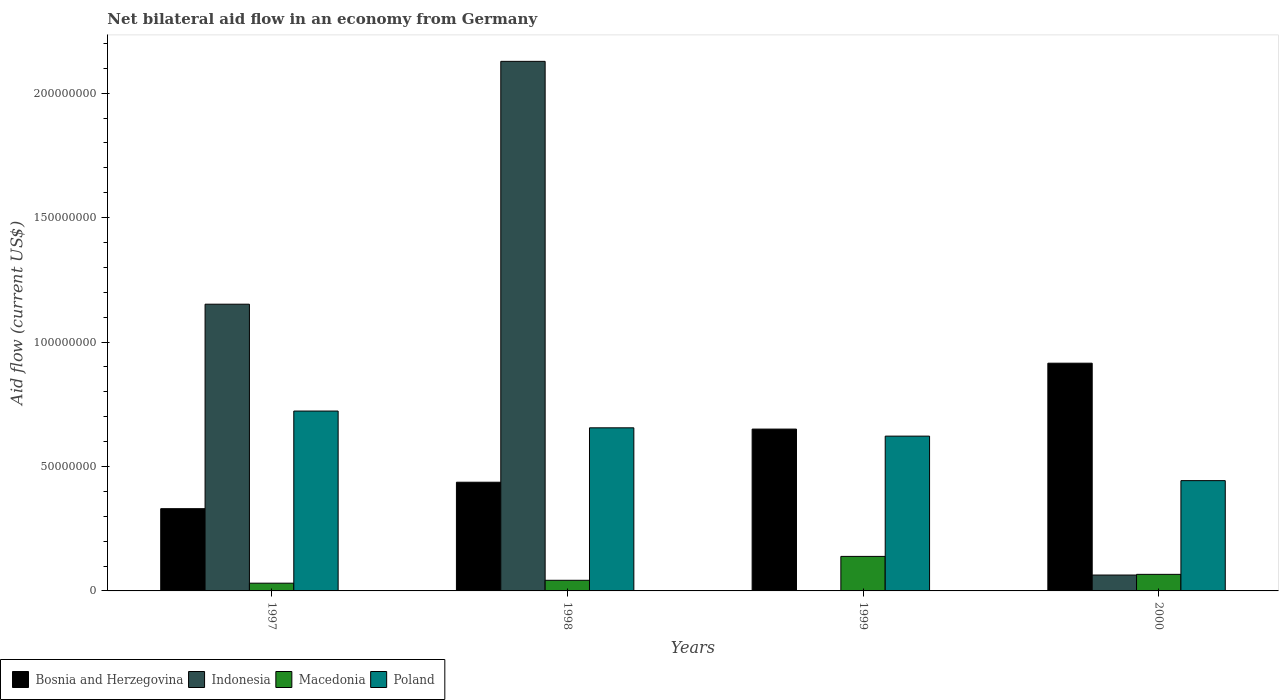How many different coloured bars are there?
Your response must be concise. 4. How many groups of bars are there?
Give a very brief answer. 4. Are the number of bars per tick equal to the number of legend labels?
Provide a succinct answer. No. How many bars are there on the 1st tick from the right?
Ensure brevity in your answer.  4. What is the label of the 4th group of bars from the left?
Offer a terse response. 2000. What is the net bilateral aid flow in Bosnia and Herzegovina in 2000?
Provide a short and direct response. 9.15e+07. Across all years, what is the maximum net bilateral aid flow in Poland?
Your answer should be compact. 7.23e+07. Across all years, what is the minimum net bilateral aid flow in Macedonia?
Make the answer very short. 3.11e+06. In which year was the net bilateral aid flow in Bosnia and Herzegovina maximum?
Ensure brevity in your answer.  2000. What is the total net bilateral aid flow in Macedonia in the graph?
Make the answer very short. 2.79e+07. What is the difference between the net bilateral aid flow in Macedonia in 1998 and that in 1999?
Offer a very short reply. -9.60e+06. What is the difference between the net bilateral aid flow in Indonesia in 2000 and the net bilateral aid flow in Macedonia in 1997?
Give a very brief answer. 3.27e+06. What is the average net bilateral aid flow in Bosnia and Herzegovina per year?
Offer a very short reply. 5.83e+07. In the year 1997, what is the difference between the net bilateral aid flow in Bosnia and Herzegovina and net bilateral aid flow in Poland?
Provide a short and direct response. -3.92e+07. What is the ratio of the net bilateral aid flow in Macedonia in 1997 to that in 1998?
Provide a short and direct response. 0.73. Is the difference between the net bilateral aid flow in Bosnia and Herzegovina in 1997 and 2000 greater than the difference between the net bilateral aid flow in Poland in 1997 and 2000?
Offer a terse response. No. What is the difference between the highest and the second highest net bilateral aid flow in Bosnia and Herzegovina?
Your response must be concise. 2.65e+07. What is the difference between the highest and the lowest net bilateral aid flow in Bosnia and Herzegovina?
Ensure brevity in your answer.  5.85e+07. In how many years, is the net bilateral aid flow in Macedonia greater than the average net bilateral aid flow in Macedonia taken over all years?
Your answer should be compact. 1. Is the sum of the net bilateral aid flow in Poland in 1997 and 1998 greater than the maximum net bilateral aid flow in Macedonia across all years?
Offer a terse response. Yes. Is it the case that in every year, the sum of the net bilateral aid flow in Macedonia and net bilateral aid flow in Bosnia and Herzegovina is greater than the sum of net bilateral aid flow in Poland and net bilateral aid flow in Indonesia?
Your answer should be compact. No. How many years are there in the graph?
Provide a short and direct response. 4. What is the difference between two consecutive major ticks on the Y-axis?
Your answer should be compact. 5.00e+07. Are the values on the major ticks of Y-axis written in scientific E-notation?
Your response must be concise. No. Where does the legend appear in the graph?
Your answer should be very brief. Bottom left. What is the title of the graph?
Give a very brief answer. Net bilateral aid flow in an economy from Germany. Does "Paraguay" appear as one of the legend labels in the graph?
Offer a very short reply. No. What is the label or title of the X-axis?
Make the answer very short. Years. What is the Aid flow (current US$) in Bosnia and Herzegovina in 1997?
Keep it short and to the point. 3.30e+07. What is the Aid flow (current US$) in Indonesia in 1997?
Make the answer very short. 1.15e+08. What is the Aid flow (current US$) in Macedonia in 1997?
Offer a terse response. 3.11e+06. What is the Aid flow (current US$) in Poland in 1997?
Offer a very short reply. 7.23e+07. What is the Aid flow (current US$) of Bosnia and Herzegovina in 1998?
Make the answer very short. 4.37e+07. What is the Aid flow (current US$) of Indonesia in 1998?
Make the answer very short. 2.13e+08. What is the Aid flow (current US$) in Macedonia in 1998?
Keep it short and to the point. 4.27e+06. What is the Aid flow (current US$) in Poland in 1998?
Ensure brevity in your answer.  6.55e+07. What is the Aid flow (current US$) of Bosnia and Herzegovina in 1999?
Provide a short and direct response. 6.50e+07. What is the Aid flow (current US$) of Indonesia in 1999?
Provide a succinct answer. 0. What is the Aid flow (current US$) of Macedonia in 1999?
Provide a short and direct response. 1.39e+07. What is the Aid flow (current US$) of Poland in 1999?
Give a very brief answer. 6.22e+07. What is the Aid flow (current US$) of Bosnia and Herzegovina in 2000?
Give a very brief answer. 9.15e+07. What is the Aid flow (current US$) in Indonesia in 2000?
Your answer should be very brief. 6.38e+06. What is the Aid flow (current US$) in Macedonia in 2000?
Give a very brief answer. 6.66e+06. What is the Aid flow (current US$) in Poland in 2000?
Provide a short and direct response. 4.43e+07. Across all years, what is the maximum Aid flow (current US$) of Bosnia and Herzegovina?
Your answer should be very brief. 9.15e+07. Across all years, what is the maximum Aid flow (current US$) of Indonesia?
Your answer should be very brief. 2.13e+08. Across all years, what is the maximum Aid flow (current US$) of Macedonia?
Your response must be concise. 1.39e+07. Across all years, what is the maximum Aid flow (current US$) in Poland?
Keep it short and to the point. 7.23e+07. Across all years, what is the minimum Aid flow (current US$) in Bosnia and Herzegovina?
Offer a very short reply. 3.30e+07. Across all years, what is the minimum Aid flow (current US$) of Indonesia?
Your response must be concise. 0. Across all years, what is the minimum Aid flow (current US$) in Macedonia?
Your response must be concise. 3.11e+06. Across all years, what is the minimum Aid flow (current US$) of Poland?
Provide a succinct answer. 4.43e+07. What is the total Aid flow (current US$) in Bosnia and Herzegovina in the graph?
Give a very brief answer. 2.33e+08. What is the total Aid flow (current US$) of Indonesia in the graph?
Make the answer very short. 3.34e+08. What is the total Aid flow (current US$) of Macedonia in the graph?
Offer a terse response. 2.79e+07. What is the total Aid flow (current US$) of Poland in the graph?
Your answer should be compact. 2.44e+08. What is the difference between the Aid flow (current US$) in Bosnia and Herzegovina in 1997 and that in 1998?
Give a very brief answer. -1.06e+07. What is the difference between the Aid flow (current US$) in Indonesia in 1997 and that in 1998?
Offer a very short reply. -9.76e+07. What is the difference between the Aid flow (current US$) of Macedonia in 1997 and that in 1998?
Provide a short and direct response. -1.16e+06. What is the difference between the Aid flow (current US$) in Poland in 1997 and that in 1998?
Offer a very short reply. 6.74e+06. What is the difference between the Aid flow (current US$) of Bosnia and Herzegovina in 1997 and that in 1999?
Ensure brevity in your answer.  -3.20e+07. What is the difference between the Aid flow (current US$) of Macedonia in 1997 and that in 1999?
Make the answer very short. -1.08e+07. What is the difference between the Aid flow (current US$) of Poland in 1997 and that in 1999?
Make the answer very short. 1.01e+07. What is the difference between the Aid flow (current US$) of Bosnia and Herzegovina in 1997 and that in 2000?
Make the answer very short. -5.85e+07. What is the difference between the Aid flow (current US$) in Indonesia in 1997 and that in 2000?
Your answer should be very brief. 1.09e+08. What is the difference between the Aid flow (current US$) of Macedonia in 1997 and that in 2000?
Keep it short and to the point. -3.55e+06. What is the difference between the Aid flow (current US$) in Poland in 1997 and that in 2000?
Give a very brief answer. 2.80e+07. What is the difference between the Aid flow (current US$) in Bosnia and Herzegovina in 1998 and that in 1999?
Offer a very short reply. -2.14e+07. What is the difference between the Aid flow (current US$) of Macedonia in 1998 and that in 1999?
Provide a succinct answer. -9.60e+06. What is the difference between the Aid flow (current US$) of Poland in 1998 and that in 1999?
Give a very brief answer. 3.34e+06. What is the difference between the Aid flow (current US$) in Bosnia and Herzegovina in 1998 and that in 2000?
Provide a succinct answer. -4.78e+07. What is the difference between the Aid flow (current US$) of Indonesia in 1998 and that in 2000?
Your answer should be very brief. 2.06e+08. What is the difference between the Aid flow (current US$) in Macedonia in 1998 and that in 2000?
Offer a terse response. -2.39e+06. What is the difference between the Aid flow (current US$) in Poland in 1998 and that in 2000?
Your answer should be very brief. 2.12e+07. What is the difference between the Aid flow (current US$) of Bosnia and Herzegovina in 1999 and that in 2000?
Ensure brevity in your answer.  -2.65e+07. What is the difference between the Aid flow (current US$) of Macedonia in 1999 and that in 2000?
Provide a succinct answer. 7.21e+06. What is the difference between the Aid flow (current US$) in Poland in 1999 and that in 2000?
Give a very brief answer. 1.79e+07. What is the difference between the Aid flow (current US$) in Bosnia and Herzegovina in 1997 and the Aid flow (current US$) in Indonesia in 1998?
Give a very brief answer. -1.80e+08. What is the difference between the Aid flow (current US$) in Bosnia and Herzegovina in 1997 and the Aid flow (current US$) in Macedonia in 1998?
Your answer should be very brief. 2.88e+07. What is the difference between the Aid flow (current US$) in Bosnia and Herzegovina in 1997 and the Aid flow (current US$) in Poland in 1998?
Ensure brevity in your answer.  -3.25e+07. What is the difference between the Aid flow (current US$) in Indonesia in 1997 and the Aid flow (current US$) in Macedonia in 1998?
Keep it short and to the point. 1.11e+08. What is the difference between the Aid flow (current US$) of Indonesia in 1997 and the Aid flow (current US$) of Poland in 1998?
Your answer should be very brief. 4.97e+07. What is the difference between the Aid flow (current US$) of Macedonia in 1997 and the Aid flow (current US$) of Poland in 1998?
Ensure brevity in your answer.  -6.24e+07. What is the difference between the Aid flow (current US$) in Bosnia and Herzegovina in 1997 and the Aid flow (current US$) in Macedonia in 1999?
Give a very brief answer. 1.92e+07. What is the difference between the Aid flow (current US$) of Bosnia and Herzegovina in 1997 and the Aid flow (current US$) of Poland in 1999?
Give a very brief answer. -2.92e+07. What is the difference between the Aid flow (current US$) of Indonesia in 1997 and the Aid flow (current US$) of Macedonia in 1999?
Offer a very short reply. 1.01e+08. What is the difference between the Aid flow (current US$) of Indonesia in 1997 and the Aid flow (current US$) of Poland in 1999?
Offer a terse response. 5.30e+07. What is the difference between the Aid flow (current US$) in Macedonia in 1997 and the Aid flow (current US$) in Poland in 1999?
Ensure brevity in your answer.  -5.91e+07. What is the difference between the Aid flow (current US$) of Bosnia and Herzegovina in 1997 and the Aid flow (current US$) of Indonesia in 2000?
Make the answer very short. 2.67e+07. What is the difference between the Aid flow (current US$) of Bosnia and Herzegovina in 1997 and the Aid flow (current US$) of Macedonia in 2000?
Offer a terse response. 2.64e+07. What is the difference between the Aid flow (current US$) of Bosnia and Herzegovina in 1997 and the Aid flow (current US$) of Poland in 2000?
Offer a terse response. -1.13e+07. What is the difference between the Aid flow (current US$) of Indonesia in 1997 and the Aid flow (current US$) of Macedonia in 2000?
Your response must be concise. 1.09e+08. What is the difference between the Aid flow (current US$) of Indonesia in 1997 and the Aid flow (current US$) of Poland in 2000?
Offer a terse response. 7.09e+07. What is the difference between the Aid flow (current US$) of Macedonia in 1997 and the Aid flow (current US$) of Poland in 2000?
Offer a terse response. -4.12e+07. What is the difference between the Aid flow (current US$) in Bosnia and Herzegovina in 1998 and the Aid flow (current US$) in Macedonia in 1999?
Keep it short and to the point. 2.98e+07. What is the difference between the Aid flow (current US$) of Bosnia and Herzegovina in 1998 and the Aid flow (current US$) of Poland in 1999?
Make the answer very short. -1.85e+07. What is the difference between the Aid flow (current US$) of Indonesia in 1998 and the Aid flow (current US$) of Macedonia in 1999?
Provide a succinct answer. 1.99e+08. What is the difference between the Aid flow (current US$) of Indonesia in 1998 and the Aid flow (current US$) of Poland in 1999?
Your answer should be compact. 1.51e+08. What is the difference between the Aid flow (current US$) of Macedonia in 1998 and the Aid flow (current US$) of Poland in 1999?
Provide a succinct answer. -5.79e+07. What is the difference between the Aid flow (current US$) of Bosnia and Herzegovina in 1998 and the Aid flow (current US$) of Indonesia in 2000?
Give a very brief answer. 3.73e+07. What is the difference between the Aid flow (current US$) in Bosnia and Herzegovina in 1998 and the Aid flow (current US$) in Macedonia in 2000?
Offer a very short reply. 3.70e+07. What is the difference between the Aid flow (current US$) in Bosnia and Herzegovina in 1998 and the Aid flow (current US$) in Poland in 2000?
Offer a very short reply. -6.40e+05. What is the difference between the Aid flow (current US$) of Indonesia in 1998 and the Aid flow (current US$) of Macedonia in 2000?
Offer a very short reply. 2.06e+08. What is the difference between the Aid flow (current US$) in Indonesia in 1998 and the Aid flow (current US$) in Poland in 2000?
Provide a short and direct response. 1.68e+08. What is the difference between the Aid flow (current US$) of Macedonia in 1998 and the Aid flow (current US$) of Poland in 2000?
Offer a very short reply. -4.00e+07. What is the difference between the Aid flow (current US$) in Bosnia and Herzegovina in 1999 and the Aid flow (current US$) in Indonesia in 2000?
Your answer should be compact. 5.86e+07. What is the difference between the Aid flow (current US$) in Bosnia and Herzegovina in 1999 and the Aid flow (current US$) in Macedonia in 2000?
Keep it short and to the point. 5.84e+07. What is the difference between the Aid flow (current US$) of Bosnia and Herzegovina in 1999 and the Aid flow (current US$) of Poland in 2000?
Offer a very short reply. 2.07e+07. What is the difference between the Aid flow (current US$) of Macedonia in 1999 and the Aid flow (current US$) of Poland in 2000?
Keep it short and to the point. -3.04e+07. What is the average Aid flow (current US$) of Bosnia and Herzegovina per year?
Your answer should be very brief. 5.83e+07. What is the average Aid flow (current US$) of Indonesia per year?
Offer a terse response. 8.36e+07. What is the average Aid flow (current US$) of Macedonia per year?
Make the answer very short. 6.98e+06. What is the average Aid flow (current US$) in Poland per year?
Your answer should be very brief. 6.11e+07. In the year 1997, what is the difference between the Aid flow (current US$) in Bosnia and Herzegovina and Aid flow (current US$) in Indonesia?
Provide a short and direct response. -8.22e+07. In the year 1997, what is the difference between the Aid flow (current US$) in Bosnia and Herzegovina and Aid flow (current US$) in Macedonia?
Your response must be concise. 2.99e+07. In the year 1997, what is the difference between the Aid flow (current US$) in Bosnia and Herzegovina and Aid flow (current US$) in Poland?
Give a very brief answer. -3.92e+07. In the year 1997, what is the difference between the Aid flow (current US$) of Indonesia and Aid flow (current US$) of Macedonia?
Provide a succinct answer. 1.12e+08. In the year 1997, what is the difference between the Aid flow (current US$) in Indonesia and Aid flow (current US$) in Poland?
Keep it short and to the point. 4.29e+07. In the year 1997, what is the difference between the Aid flow (current US$) in Macedonia and Aid flow (current US$) in Poland?
Your answer should be very brief. -6.92e+07. In the year 1998, what is the difference between the Aid flow (current US$) of Bosnia and Herzegovina and Aid flow (current US$) of Indonesia?
Your response must be concise. -1.69e+08. In the year 1998, what is the difference between the Aid flow (current US$) of Bosnia and Herzegovina and Aid flow (current US$) of Macedonia?
Your answer should be compact. 3.94e+07. In the year 1998, what is the difference between the Aid flow (current US$) in Bosnia and Herzegovina and Aid flow (current US$) in Poland?
Give a very brief answer. -2.19e+07. In the year 1998, what is the difference between the Aid flow (current US$) in Indonesia and Aid flow (current US$) in Macedonia?
Offer a terse response. 2.09e+08. In the year 1998, what is the difference between the Aid flow (current US$) in Indonesia and Aid flow (current US$) in Poland?
Offer a terse response. 1.47e+08. In the year 1998, what is the difference between the Aid flow (current US$) of Macedonia and Aid flow (current US$) of Poland?
Your answer should be compact. -6.13e+07. In the year 1999, what is the difference between the Aid flow (current US$) of Bosnia and Herzegovina and Aid flow (current US$) of Macedonia?
Provide a short and direct response. 5.12e+07. In the year 1999, what is the difference between the Aid flow (current US$) of Bosnia and Herzegovina and Aid flow (current US$) of Poland?
Provide a succinct answer. 2.83e+06. In the year 1999, what is the difference between the Aid flow (current US$) of Macedonia and Aid flow (current US$) of Poland?
Offer a very short reply. -4.83e+07. In the year 2000, what is the difference between the Aid flow (current US$) of Bosnia and Herzegovina and Aid flow (current US$) of Indonesia?
Keep it short and to the point. 8.51e+07. In the year 2000, what is the difference between the Aid flow (current US$) in Bosnia and Herzegovina and Aid flow (current US$) in Macedonia?
Provide a short and direct response. 8.48e+07. In the year 2000, what is the difference between the Aid flow (current US$) in Bosnia and Herzegovina and Aid flow (current US$) in Poland?
Your response must be concise. 4.72e+07. In the year 2000, what is the difference between the Aid flow (current US$) of Indonesia and Aid flow (current US$) of Macedonia?
Offer a very short reply. -2.80e+05. In the year 2000, what is the difference between the Aid flow (current US$) of Indonesia and Aid flow (current US$) of Poland?
Provide a succinct answer. -3.79e+07. In the year 2000, what is the difference between the Aid flow (current US$) in Macedonia and Aid flow (current US$) in Poland?
Your answer should be very brief. -3.77e+07. What is the ratio of the Aid flow (current US$) in Bosnia and Herzegovina in 1997 to that in 1998?
Your answer should be compact. 0.76. What is the ratio of the Aid flow (current US$) in Indonesia in 1997 to that in 1998?
Ensure brevity in your answer.  0.54. What is the ratio of the Aid flow (current US$) of Macedonia in 1997 to that in 1998?
Make the answer very short. 0.73. What is the ratio of the Aid flow (current US$) in Poland in 1997 to that in 1998?
Your answer should be very brief. 1.1. What is the ratio of the Aid flow (current US$) of Bosnia and Herzegovina in 1997 to that in 1999?
Offer a terse response. 0.51. What is the ratio of the Aid flow (current US$) of Macedonia in 1997 to that in 1999?
Your answer should be very brief. 0.22. What is the ratio of the Aid flow (current US$) of Poland in 1997 to that in 1999?
Keep it short and to the point. 1.16. What is the ratio of the Aid flow (current US$) of Bosnia and Herzegovina in 1997 to that in 2000?
Give a very brief answer. 0.36. What is the ratio of the Aid flow (current US$) of Indonesia in 1997 to that in 2000?
Provide a succinct answer. 18.06. What is the ratio of the Aid flow (current US$) in Macedonia in 1997 to that in 2000?
Keep it short and to the point. 0.47. What is the ratio of the Aid flow (current US$) in Poland in 1997 to that in 2000?
Your answer should be compact. 1.63. What is the ratio of the Aid flow (current US$) in Bosnia and Herzegovina in 1998 to that in 1999?
Provide a succinct answer. 0.67. What is the ratio of the Aid flow (current US$) in Macedonia in 1998 to that in 1999?
Give a very brief answer. 0.31. What is the ratio of the Aid flow (current US$) of Poland in 1998 to that in 1999?
Your answer should be very brief. 1.05. What is the ratio of the Aid flow (current US$) in Bosnia and Herzegovina in 1998 to that in 2000?
Make the answer very short. 0.48. What is the ratio of the Aid flow (current US$) in Indonesia in 1998 to that in 2000?
Keep it short and to the point. 33.35. What is the ratio of the Aid flow (current US$) of Macedonia in 1998 to that in 2000?
Keep it short and to the point. 0.64. What is the ratio of the Aid flow (current US$) in Poland in 1998 to that in 2000?
Your answer should be very brief. 1.48. What is the ratio of the Aid flow (current US$) in Bosnia and Herzegovina in 1999 to that in 2000?
Your answer should be very brief. 0.71. What is the ratio of the Aid flow (current US$) in Macedonia in 1999 to that in 2000?
Your response must be concise. 2.08. What is the ratio of the Aid flow (current US$) of Poland in 1999 to that in 2000?
Your answer should be very brief. 1.4. What is the difference between the highest and the second highest Aid flow (current US$) in Bosnia and Herzegovina?
Your response must be concise. 2.65e+07. What is the difference between the highest and the second highest Aid flow (current US$) of Indonesia?
Offer a very short reply. 9.76e+07. What is the difference between the highest and the second highest Aid flow (current US$) of Macedonia?
Offer a very short reply. 7.21e+06. What is the difference between the highest and the second highest Aid flow (current US$) of Poland?
Give a very brief answer. 6.74e+06. What is the difference between the highest and the lowest Aid flow (current US$) of Bosnia and Herzegovina?
Keep it short and to the point. 5.85e+07. What is the difference between the highest and the lowest Aid flow (current US$) in Indonesia?
Provide a short and direct response. 2.13e+08. What is the difference between the highest and the lowest Aid flow (current US$) of Macedonia?
Make the answer very short. 1.08e+07. What is the difference between the highest and the lowest Aid flow (current US$) of Poland?
Give a very brief answer. 2.80e+07. 